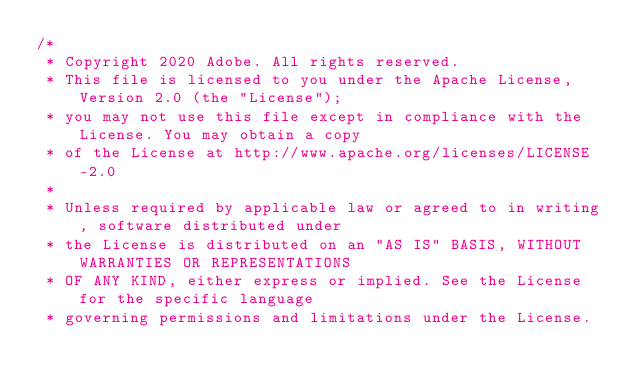Convert code to text. <code><loc_0><loc_0><loc_500><loc_500><_TypeScript_>/*
 * Copyright 2020 Adobe. All rights reserved.
 * This file is licensed to you under the Apache License, Version 2.0 (the "License");
 * you may not use this file except in compliance with the License. You may obtain a copy
 * of the License at http://www.apache.org/licenses/LICENSE-2.0
 *
 * Unless required by applicable law or agreed to in writing, software distributed under
 * the License is distributed on an "AS IS" BASIS, WITHOUT WARRANTIES OR REPRESENTATIONS
 * OF ANY KIND, either express or implied. See the License for the specific language
 * governing permissions and limitations under the License.</code> 